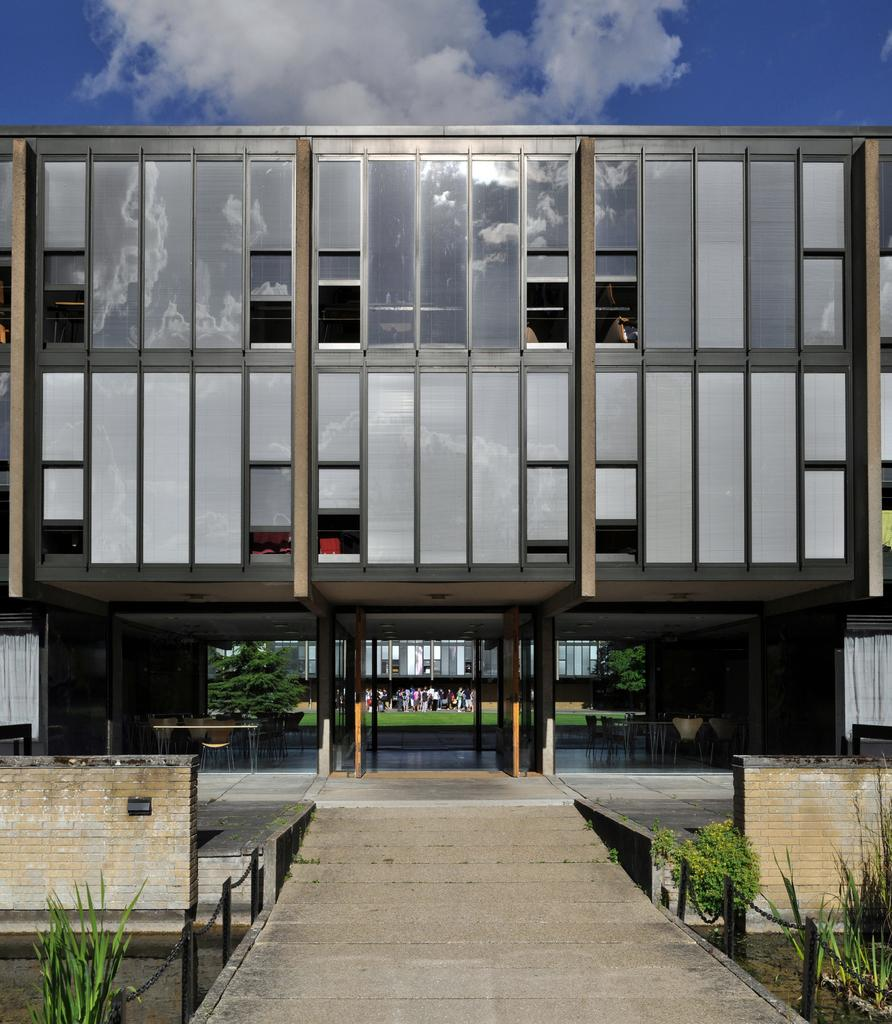What type of structure can be seen in the image? There is a building in the image. What natural elements are present in the image? There are plants, trees, and the sky visible in the image. What architectural features can be observed in the image? There are windows, a fence, poles, curtains, walls, and a building in the image. Are there any living beings in the image? Yes, there are people in the image. What can be seen in the background of the image? The sky is visible in the background of the image, with clouds present. How many toads are sitting on the fence in the image? There are no toads present in the image. What type of transport is visible in the image? There is no transport visible in the image. 